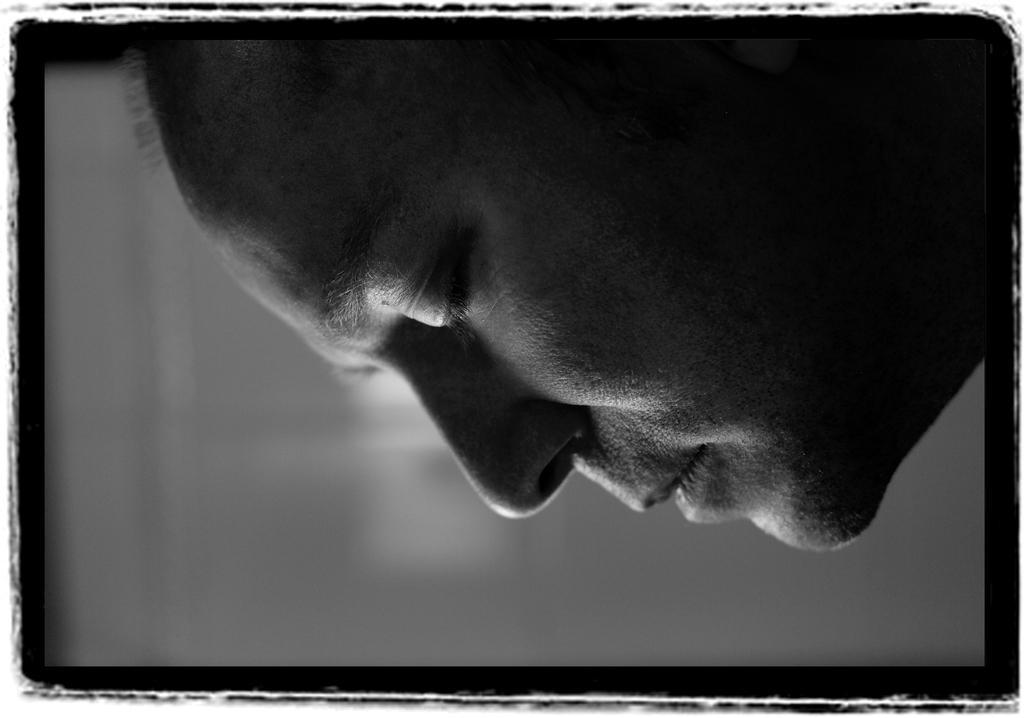How would you summarize this image in a sentence or two? In this image we can see face of a person. The background is blurry. 